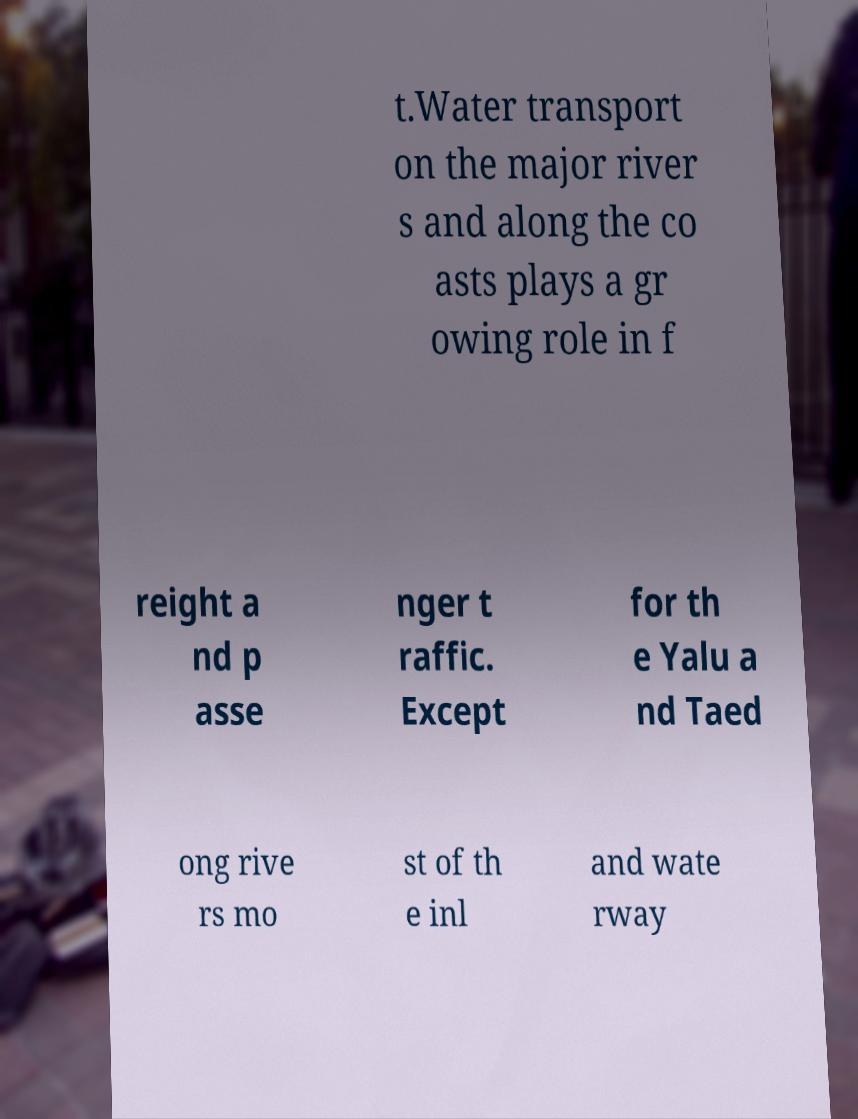Could you assist in decoding the text presented in this image and type it out clearly? t.Water transport on the major river s and along the co asts plays a gr owing role in f reight a nd p asse nger t raffic. Except for th e Yalu a nd Taed ong rive rs mo st of th e inl and wate rway 